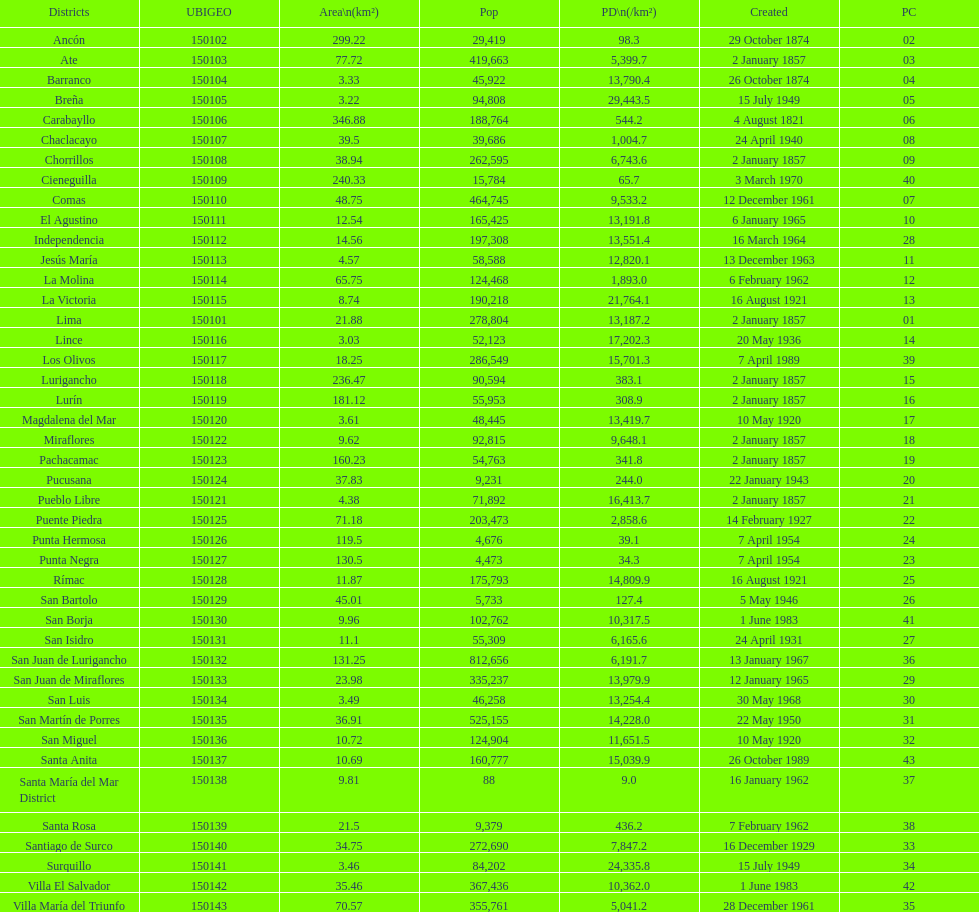What district has the least amount of population? Santa María del Mar District. 